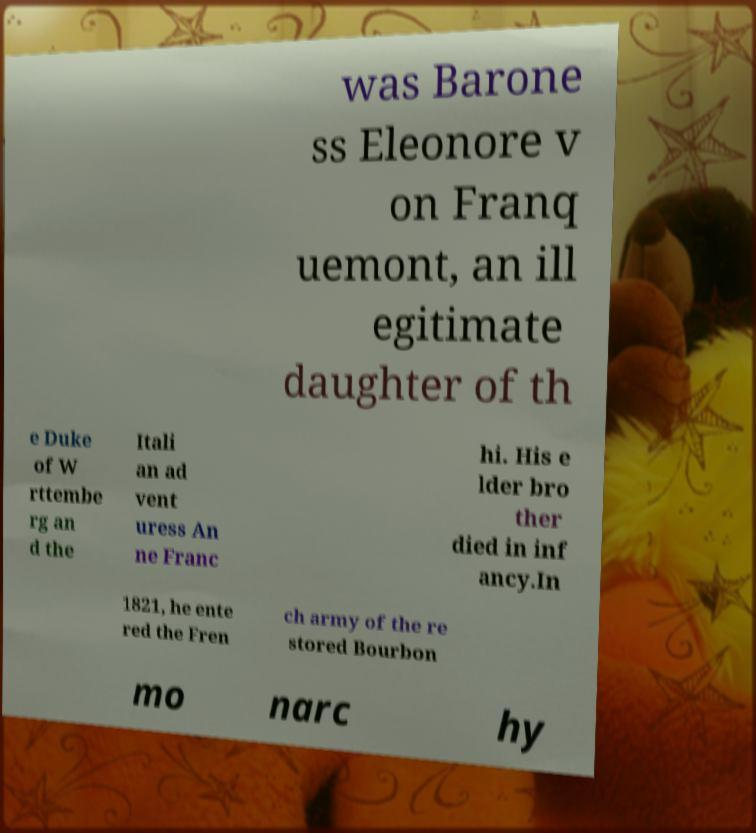Could you extract and type out the text from this image? was Barone ss Eleonore v on Franq uemont, an ill egitimate daughter of th e Duke of W rttembe rg an d the Itali an ad vent uress An ne Franc hi. His e lder bro ther died in inf ancy.In 1821, he ente red the Fren ch army of the re stored Bourbon mo narc hy 